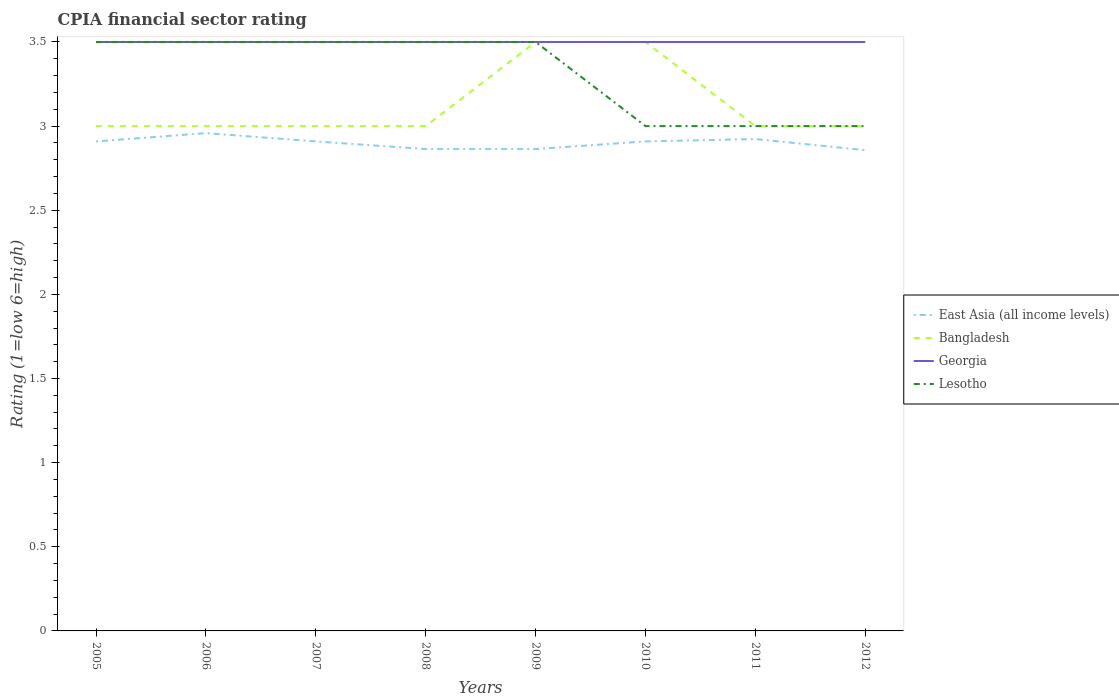Across all years, what is the maximum CPIA rating in Lesotho?
Provide a succinct answer. 3. What is the total CPIA rating in Georgia in the graph?
Ensure brevity in your answer.  0. What is the difference between the highest and the second highest CPIA rating in East Asia (all income levels)?
Offer a terse response. 0.1. How many years are there in the graph?
Ensure brevity in your answer.  8. What is the difference between two consecutive major ticks on the Y-axis?
Offer a terse response. 0.5. Are the values on the major ticks of Y-axis written in scientific E-notation?
Your response must be concise. No. Does the graph contain any zero values?
Offer a terse response. No. How many legend labels are there?
Make the answer very short. 4. How are the legend labels stacked?
Offer a terse response. Vertical. What is the title of the graph?
Your answer should be very brief. CPIA financial sector rating. What is the label or title of the X-axis?
Ensure brevity in your answer.  Years. What is the Rating (1=low 6=high) in East Asia (all income levels) in 2005?
Ensure brevity in your answer.  2.91. What is the Rating (1=low 6=high) in Bangladesh in 2005?
Your answer should be compact. 3. What is the Rating (1=low 6=high) in Georgia in 2005?
Make the answer very short. 3.5. What is the Rating (1=low 6=high) in Lesotho in 2005?
Offer a terse response. 3.5. What is the Rating (1=low 6=high) of East Asia (all income levels) in 2006?
Keep it short and to the point. 2.96. What is the Rating (1=low 6=high) of Georgia in 2006?
Your answer should be compact. 3.5. What is the Rating (1=low 6=high) in East Asia (all income levels) in 2007?
Provide a short and direct response. 2.91. What is the Rating (1=low 6=high) of Bangladesh in 2007?
Keep it short and to the point. 3. What is the Rating (1=low 6=high) in East Asia (all income levels) in 2008?
Your answer should be compact. 2.86. What is the Rating (1=low 6=high) in Lesotho in 2008?
Give a very brief answer. 3.5. What is the Rating (1=low 6=high) of East Asia (all income levels) in 2009?
Provide a short and direct response. 2.86. What is the Rating (1=low 6=high) in East Asia (all income levels) in 2010?
Your response must be concise. 2.91. What is the Rating (1=low 6=high) in Bangladesh in 2010?
Ensure brevity in your answer.  3.5. What is the Rating (1=low 6=high) of Georgia in 2010?
Your answer should be compact. 3.5. What is the Rating (1=low 6=high) in Lesotho in 2010?
Provide a short and direct response. 3. What is the Rating (1=low 6=high) of East Asia (all income levels) in 2011?
Your answer should be very brief. 2.92. What is the Rating (1=low 6=high) in East Asia (all income levels) in 2012?
Your response must be concise. 2.86. What is the Rating (1=low 6=high) of Lesotho in 2012?
Your answer should be very brief. 3. Across all years, what is the maximum Rating (1=low 6=high) of East Asia (all income levels)?
Ensure brevity in your answer.  2.96. Across all years, what is the maximum Rating (1=low 6=high) in Bangladesh?
Offer a terse response. 3.5. Across all years, what is the maximum Rating (1=low 6=high) of Georgia?
Your answer should be compact. 3.5. Across all years, what is the minimum Rating (1=low 6=high) of East Asia (all income levels)?
Keep it short and to the point. 2.86. Across all years, what is the minimum Rating (1=low 6=high) in Bangladesh?
Give a very brief answer. 3. What is the total Rating (1=low 6=high) in East Asia (all income levels) in the graph?
Offer a very short reply. 23.19. What is the total Rating (1=low 6=high) in Bangladesh in the graph?
Offer a terse response. 25. What is the total Rating (1=low 6=high) in Georgia in the graph?
Make the answer very short. 28. What is the total Rating (1=low 6=high) of Lesotho in the graph?
Your response must be concise. 26.5. What is the difference between the Rating (1=low 6=high) of East Asia (all income levels) in 2005 and that in 2006?
Offer a terse response. -0.05. What is the difference between the Rating (1=low 6=high) of Lesotho in 2005 and that in 2006?
Offer a very short reply. 0. What is the difference between the Rating (1=low 6=high) of East Asia (all income levels) in 2005 and that in 2007?
Provide a short and direct response. 0. What is the difference between the Rating (1=low 6=high) in East Asia (all income levels) in 2005 and that in 2008?
Ensure brevity in your answer.  0.05. What is the difference between the Rating (1=low 6=high) of Bangladesh in 2005 and that in 2008?
Offer a very short reply. 0. What is the difference between the Rating (1=low 6=high) in East Asia (all income levels) in 2005 and that in 2009?
Your answer should be very brief. 0.05. What is the difference between the Rating (1=low 6=high) in Georgia in 2005 and that in 2009?
Your response must be concise. 0. What is the difference between the Rating (1=low 6=high) in Lesotho in 2005 and that in 2009?
Ensure brevity in your answer.  0. What is the difference between the Rating (1=low 6=high) of Lesotho in 2005 and that in 2010?
Your response must be concise. 0.5. What is the difference between the Rating (1=low 6=high) of East Asia (all income levels) in 2005 and that in 2011?
Provide a succinct answer. -0.01. What is the difference between the Rating (1=low 6=high) of Georgia in 2005 and that in 2011?
Give a very brief answer. 0. What is the difference between the Rating (1=low 6=high) in Lesotho in 2005 and that in 2011?
Offer a terse response. 0.5. What is the difference between the Rating (1=low 6=high) of East Asia (all income levels) in 2005 and that in 2012?
Make the answer very short. 0.05. What is the difference between the Rating (1=low 6=high) in Bangladesh in 2005 and that in 2012?
Your answer should be compact. 0. What is the difference between the Rating (1=low 6=high) of Georgia in 2005 and that in 2012?
Provide a short and direct response. 0. What is the difference between the Rating (1=low 6=high) of East Asia (all income levels) in 2006 and that in 2007?
Offer a terse response. 0.05. What is the difference between the Rating (1=low 6=high) of Georgia in 2006 and that in 2007?
Your answer should be very brief. 0. What is the difference between the Rating (1=low 6=high) in East Asia (all income levels) in 2006 and that in 2008?
Keep it short and to the point. 0.09. What is the difference between the Rating (1=low 6=high) in Bangladesh in 2006 and that in 2008?
Provide a succinct answer. 0. What is the difference between the Rating (1=low 6=high) of Georgia in 2006 and that in 2008?
Provide a succinct answer. 0. What is the difference between the Rating (1=low 6=high) of Lesotho in 2006 and that in 2008?
Give a very brief answer. 0. What is the difference between the Rating (1=low 6=high) of East Asia (all income levels) in 2006 and that in 2009?
Make the answer very short. 0.09. What is the difference between the Rating (1=low 6=high) of Bangladesh in 2006 and that in 2009?
Your answer should be very brief. -0.5. What is the difference between the Rating (1=low 6=high) in Georgia in 2006 and that in 2009?
Your answer should be very brief. 0. What is the difference between the Rating (1=low 6=high) in East Asia (all income levels) in 2006 and that in 2010?
Provide a succinct answer. 0.05. What is the difference between the Rating (1=low 6=high) in Bangladesh in 2006 and that in 2010?
Ensure brevity in your answer.  -0.5. What is the difference between the Rating (1=low 6=high) of East Asia (all income levels) in 2006 and that in 2011?
Offer a terse response. 0.04. What is the difference between the Rating (1=low 6=high) in Bangladesh in 2006 and that in 2011?
Your response must be concise. 0. What is the difference between the Rating (1=low 6=high) in Georgia in 2006 and that in 2011?
Offer a very short reply. 0. What is the difference between the Rating (1=low 6=high) of Lesotho in 2006 and that in 2011?
Give a very brief answer. 0.5. What is the difference between the Rating (1=low 6=high) of East Asia (all income levels) in 2006 and that in 2012?
Your answer should be compact. 0.1. What is the difference between the Rating (1=low 6=high) in Lesotho in 2006 and that in 2012?
Keep it short and to the point. 0.5. What is the difference between the Rating (1=low 6=high) of East Asia (all income levels) in 2007 and that in 2008?
Offer a very short reply. 0.05. What is the difference between the Rating (1=low 6=high) in Bangladesh in 2007 and that in 2008?
Keep it short and to the point. 0. What is the difference between the Rating (1=low 6=high) in Lesotho in 2007 and that in 2008?
Offer a very short reply. 0. What is the difference between the Rating (1=low 6=high) in East Asia (all income levels) in 2007 and that in 2009?
Your response must be concise. 0.05. What is the difference between the Rating (1=low 6=high) of Bangladesh in 2007 and that in 2009?
Make the answer very short. -0.5. What is the difference between the Rating (1=low 6=high) in Georgia in 2007 and that in 2009?
Your response must be concise. 0. What is the difference between the Rating (1=low 6=high) in Georgia in 2007 and that in 2010?
Your answer should be compact. 0. What is the difference between the Rating (1=low 6=high) in East Asia (all income levels) in 2007 and that in 2011?
Your answer should be compact. -0.01. What is the difference between the Rating (1=low 6=high) in Bangladesh in 2007 and that in 2011?
Your answer should be very brief. 0. What is the difference between the Rating (1=low 6=high) in Georgia in 2007 and that in 2011?
Provide a short and direct response. 0. What is the difference between the Rating (1=low 6=high) in East Asia (all income levels) in 2007 and that in 2012?
Your response must be concise. 0.05. What is the difference between the Rating (1=low 6=high) of Lesotho in 2007 and that in 2012?
Offer a terse response. 0.5. What is the difference between the Rating (1=low 6=high) in East Asia (all income levels) in 2008 and that in 2010?
Provide a succinct answer. -0.05. What is the difference between the Rating (1=low 6=high) of Georgia in 2008 and that in 2010?
Provide a short and direct response. 0. What is the difference between the Rating (1=low 6=high) of East Asia (all income levels) in 2008 and that in 2011?
Keep it short and to the point. -0.06. What is the difference between the Rating (1=low 6=high) in Bangladesh in 2008 and that in 2011?
Your answer should be very brief. 0. What is the difference between the Rating (1=low 6=high) of Georgia in 2008 and that in 2011?
Keep it short and to the point. 0. What is the difference between the Rating (1=low 6=high) in Lesotho in 2008 and that in 2011?
Ensure brevity in your answer.  0.5. What is the difference between the Rating (1=low 6=high) in East Asia (all income levels) in 2008 and that in 2012?
Give a very brief answer. 0.01. What is the difference between the Rating (1=low 6=high) in Bangladesh in 2008 and that in 2012?
Your answer should be compact. 0. What is the difference between the Rating (1=low 6=high) in Lesotho in 2008 and that in 2012?
Provide a short and direct response. 0.5. What is the difference between the Rating (1=low 6=high) of East Asia (all income levels) in 2009 and that in 2010?
Provide a short and direct response. -0.05. What is the difference between the Rating (1=low 6=high) in Bangladesh in 2009 and that in 2010?
Ensure brevity in your answer.  0. What is the difference between the Rating (1=low 6=high) of Lesotho in 2009 and that in 2010?
Offer a very short reply. 0.5. What is the difference between the Rating (1=low 6=high) of East Asia (all income levels) in 2009 and that in 2011?
Provide a short and direct response. -0.06. What is the difference between the Rating (1=low 6=high) in East Asia (all income levels) in 2009 and that in 2012?
Your answer should be very brief. 0.01. What is the difference between the Rating (1=low 6=high) in Georgia in 2009 and that in 2012?
Provide a succinct answer. 0. What is the difference between the Rating (1=low 6=high) of Lesotho in 2009 and that in 2012?
Offer a terse response. 0.5. What is the difference between the Rating (1=low 6=high) in East Asia (all income levels) in 2010 and that in 2011?
Give a very brief answer. -0.01. What is the difference between the Rating (1=low 6=high) of Georgia in 2010 and that in 2011?
Give a very brief answer. 0. What is the difference between the Rating (1=low 6=high) of East Asia (all income levels) in 2010 and that in 2012?
Keep it short and to the point. 0.05. What is the difference between the Rating (1=low 6=high) of Georgia in 2010 and that in 2012?
Offer a very short reply. 0. What is the difference between the Rating (1=low 6=high) in East Asia (all income levels) in 2011 and that in 2012?
Provide a short and direct response. 0.07. What is the difference between the Rating (1=low 6=high) in East Asia (all income levels) in 2005 and the Rating (1=low 6=high) in Bangladesh in 2006?
Provide a short and direct response. -0.09. What is the difference between the Rating (1=low 6=high) in East Asia (all income levels) in 2005 and the Rating (1=low 6=high) in Georgia in 2006?
Ensure brevity in your answer.  -0.59. What is the difference between the Rating (1=low 6=high) in East Asia (all income levels) in 2005 and the Rating (1=low 6=high) in Lesotho in 2006?
Your answer should be very brief. -0.59. What is the difference between the Rating (1=low 6=high) of Georgia in 2005 and the Rating (1=low 6=high) of Lesotho in 2006?
Make the answer very short. 0. What is the difference between the Rating (1=low 6=high) of East Asia (all income levels) in 2005 and the Rating (1=low 6=high) of Bangladesh in 2007?
Offer a terse response. -0.09. What is the difference between the Rating (1=low 6=high) of East Asia (all income levels) in 2005 and the Rating (1=low 6=high) of Georgia in 2007?
Give a very brief answer. -0.59. What is the difference between the Rating (1=low 6=high) of East Asia (all income levels) in 2005 and the Rating (1=low 6=high) of Lesotho in 2007?
Your answer should be compact. -0.59. What is the difference between the Rating (1=low 6=high) of East Asia (all income levels) in 2005 and the Rating (1=low 6=high) of Bangladesh in 2008?
Offer a very short reply. -0.09. What is the difference between the Rating (1=low 6=high) of East Asia (all income levels) in 2005 and the Rating (1=low 6=high) of Georgia in 2008?
Ensure brevity in your answer.  -0.59. What is the difference between the Rating (1=low 6=high) of East Asia (all income levels) in 2005 and the Rating (1=low 6=high) of Lesotho in 2008?
Keep it short and to the point. -0.59. What is the difference between the Rating (1=low 6=high) in Bangladesh in 2005 and the Rating (1=low 6=high) in Georgia in 2008?
Offer a very short reply. -0.5. What is the difference between the Rating (1=low 6=high) of Bangladesh in 2005 and the Rating (1=low 6=high) of Lesotho in 2008?
Keep it short and to the point. -0.5. What is the difference between the Rating (1=low 6=high) in Georgia in 2005 and the Rating (1=low 6=high) in Lesotho in 2008?
Make the answer very short. 0. What is the difference between the Rating (1=low 6=high) in East Asia (all income levels) in 2005 and the Rating (1=low 6=high) in Bangladesh in 2009?
Provide a succinct answer. -0.59. What is the difference between the Rating (1=low 6=high) of East Asia (all income levels) in 2005 and the Rating (1=low 6=high) of Georgia in 2009?
Your answer should be compact. -0.59. What is the difference between the Rating (1=low 6=high) of East Asia (all income levels) in 2005 and the Rating (1=low 6=high) of Lesotho in 2009?
Offer a very short reply. -0.59. What is the difference between the Rating (1=low 6=high) in Bangladesh in 2005 and the Rating (1=low 6=high) in Lesotho in 2009?
Your answer should be very brief. -0.5. What is the difference between the Rating (1=low 6=high) of Georgia in 2005 and the Rating (1=low 6=high) of Lesotho in 2009?
Offer a terse response. 0. What is the difference between the Rating (1=low 6=high) in East Asia (all income levels) in 2005 and the Rating (1=low 6=high) in Bangladesh in 2010?
Your answer should be compact. -0.59. What is the difference between the Rating (1=low 6=high) of East Asia (all income levels) in 2005 and the Rating (1=low 6=high) of Georgia in 2010?
Your answer should be compact. -0.59. What is the difference between the Rating (1=low 6=high) in East Asia (all income levels) in 2005 and the Rating (1=low 6=high) in Lesotho in 2010?
Provide a succinct answer. -0.09. What is the difference between the Rating (1=low 6=high) of Bangladesh in 2005 and the Rating (1=low 6=high) of Georgia in 2010?
Provide a short and direct response. -0.5. What is the difference between the Rating (1=low 6=high) in East Asia (all income levels) in 2005 and the Rating (1=low 6=high) in Bangladesh in 2011?
Provide a succinct answer. -0.09. What is the difference between the Rating (1=low 6=high) in East Asia (all income levels) in 2005 and the Rating (1=low 6=high) in Georgia in 2011?
Ensure brevity in your answer.  -0.59. What is the difference between the Rating (1=low 6=high) in East Asia (all income levels) in 2005 and the Rating (1=low 6=high) in Lesotho in 2011?
Ensure brevity in your answer.  -0.09. What is the difference between the Rating (1=low 6=high) in Bangladesh in 2005 and the Rating (1=low 6=high) in Lesotho in 2011?
Your answer should be compact. 0. What is the difference between the Rating (1=low 6=high) in East Asia (all income levels) in 2005 and the Rating (1=low 6=high) in Bangladesh in 2012?
Your answer should be very brief. -0.09. What is the difference between the Rating (1=low 6=high) of East Asia (all income levels) in 2005 and the Rating (1=low 6=high) of Georgia in 2012?
Offer a very short reply. -0.59. What is the difference between the Rating (1=low 6=high) of East Asia (all income levels) in 2005 and the Rating (1=low 6=high) of Lesotho in 2012?
Provide a succinct answer. -0.09. What is the difference between the Rating (1=low 6=high) of Bangladesh in 2005 and the Rating (1=low 6=high) of Lesotho in 2012?
Offer a very short reply. 0. What is the difference between the Rating (1=low 6=high) in Georgia in 2005 and the Rating (1=low 6=high) in Lesotho in 2012?
Provide a succinct answer. 0.5. What is the difference between the Rating (1=low 6=high) of East Asia (all income levels) in 2006 and the Rating (1=low 6=high) of Bangladesh in 2007?
Your answer should be very brief. -0.04. What is the difference between the Rating (1=low 6=high) in East Asia (all income levels) in 2006 and the Rating (1=low 6=high) in Georgia in 2007?
Offer a terse response. -0.54. What is the difference between the Rating (1=low 6=high) in East Asia (all income levels) in 2006 and the Rating (1=low 6=high) in Lesotho in 2007?
Provide a succinct answer. -0.54. What is the difference between the Rating (1=low 6=high) in Bangladesh in 2006 and the Rating (1=low 6=high) in Lesotho in 2007?
Your response must be concise. -0.5. What is the difference between the Rating (1=low 6=high) of Georgia in 2006 and the Rating (1=low 6=high) of Lesotho in 2007?
Your answer should be very brief. 0. What is the difference between the Rating (1=low 6=high) in East Asia (all income levels) in 2006 and the Rating (1=low 6=high) in Bangladesh in 2008?
Give a very brief answer. -0.04. What is the difference between the Rating (1=low 6=high) in East Asia (all income levels) in 2006 and the Rating (1=low 6=high) in Georgia in 2008?
Make the answer very short. -0.54. What is the difference between the Rating (1=low 6=high) of East Asia (all income levels) in 2006 and the Rating (1=low 6=high) of Lesotho in 2008?
Provide a short and direct response. -0.54. What is the difference between the Rating (1=low 6=high) of Bangladesh in 2006 and the Rating (1=low 6=high) of Georgia in 2008?
Provide a short and direct response. -0.5. What is the difference between the Rating (1=low 6=high) of East Asia (all income levels) in 2006 and the Rating (1=low 6=high) of Bangladesh in 2009?
Offer a very short reply. -0.54. What is the difference between the Rating (1=low 6=high) in East Asia (all income levels) in 2006 and the Rating (1=low 6=high) in Georgia in 2009?
Offer a terse response. -0.54. What is the difference between the Rating (1=low 6=high) in East Asia (all income levels) in 2006 and the Rating (1=low 6=high) in Lesotho in 2009?
Provide a short and direct response. -0.54. What is the difference between the Rating (1=low 6=high) in Bangladesh in 2006 and the Rating (1=low 6=high) in Lesotho in 2009?
Your response must be concise. -0.5. What is the difference between the Rating (1=low 6=high) in Georgia in 2006 and the Rating (1=low 6=high) in Lesotho in 2009?
Offer a terse response. 0. What is the difference between the Rating (1=low 6=high) in East Asia (all income levels) in 2006 and the Rating (1=low 6=high) in Bangladesh in 2010?
Keep it short and to the point. -0.54. What is the difference between the Rating (1=low 6=high) of East Asia (all income levels) in 2006 and the Rating (1=low 6=high) of Georgia in 2010?
Offer a very short reply. -0.54. What is the difference between the Rating (1=low 6=high) in East Asia (all income levels) in 2006 and the Rating (1=low 6=high) in Lesotho in 2010?
Your answer should be compact. -0.04. What is the difference between the Rating (1=low 6=high) in East Asia (all income levels) in 2006 and the Rating (1=low 6=high) in Bangladesh in 2011?
Keep it short and to the point. -0.04. What is the difference between the Rating (1=low 6=high) of East Asia (all income levels) in 2006 and the Rating (1=low 6=high) of Georgia in 2011?
Your answer should be very brief. -0.54. What is the difference between the Rating (1=low 6=high) in East Asia (all income levels) in 2006 and the Rating (1=low 6=high) in Lesotho in 2011?
Make the answer very short. -0.04. What is the difference between the Rating (1=low 6=high) of Bangladesh in 2006 and the Rating (1=low 6=high) of Lesotho in 2011?
Make the answer very short. 0. What is the difference between the Rating (1=low 6=high) of Georgia in 2006 and the Rating (1=low 6=high) of Lesotho in 2011?
Provide a short and direct response. 0.5. What is the difference between the Rating (1=low 6=high) of East Asia (all income levels) in 2006 and the Rating (1=low 6=high) of Bangladesh in 2012?
Your answer should be very brief. -0.04. What is the difference between the Rating (1=low 6=high) of East Asia (all income levels) in 2006 and the Rating (1=low 6=high) of Georgia in 2012?
Provide a succinct answer. -0.54. What is the difference between the Rating (1=low 6=high) in East Asia (all income levels) in 2006 and the Rating (1=low 6=high) in Lesotho in 2012?
Make the answer very short. -0.04. What is the difference between the Rating (1=low 6=high) of Bangladesh in 2006 and the Rating (1=low 6=high) of Georgia in 2012?
Keep it short and to the point. -0.5. What is the difference between the Rating (1=low 6=high) of Bangladesh in 2006 and the Rating (1=low 6=high) of Lesotho in 2012?
Keep it short and to the point. 0. What is the difference between the Rating (1=low 6=high) of East Asia (all income levels) in 2007 and the Rating (1=low 6=high) of Bangladesh in 2008?
Ensure brevity in your answer.  -0.09. What is the difference between the Rating (1=low 6=high) in East Asia (all income levels) in 2007 and the Rating (1=low 6=high) in Georgia in 2008?
Make the answer very short. -0.59. What is the difference between the Rating (1=low 6=high) in East Asia (all income levels) in 2007 and the Rating (1=low 6=high) in Lesotho in 2008?
Your response must be concise. -0.59. What is the difference between the Rating (1=low 6=high) in Bangladesh in 2007 and the Rating (1=low 6=high) in Georgia in 2008?
Provide a short and direct response. -0.5. What is the difference between the Rating (1=low 6=high) in Bangladesh in 2007 and the Rating (1=low 6=high) in Lesotho in 2008?
Your response must be concise. -0.5. What is the difference between the Rating (1=low 6=high) in East Asia (all income levels) in 2007 and the Rating (1=low 6=high) in Bangladesh in 2009?
Give a very brief answer. -0.59. What is the difference between the Rating (1=low 6=high) in East Asia (all income levels) in 2007 and the Rating (1=low 6=high) in Georgia in 2009?
Make the answer very short. -0.59. What is the difference between the Rating (1=low 6=high) in East Asia (all income levels) in 2007 and the Rating (1=low 6=high) in Lesotho in 2009?
Provide a short and direct response. -0.59. What is the difference between the Rating (1=low 6=high) of Georgia in 2007 and the Rating (1=low 6=high) of Lesotho in 2009?
Your answer should be very brief. 0. What is the difference between the Rating (1=low 6=high) of East Asia (all income levels) in 2007 and the Rating (1=low 6=high) of Bangladesh in 2010?
Make the answer very short. -0.59. What is the difference between the Rating (1=low 6=high) of East Asia (all income levels) in 2007 and the Rating (1=low 6=high) of Georgia in 2010?
Your answer should be very brief. -0.59. What is the difference between the Rating (1=low 6=high) of East Asia (all income levels) in 2007 and the Rating (1=low 6=high) of Lesotho in 2010?
Offer a terse response. -0.09. What is the difference between the Rating (1=low 6=high) in Bangladesh in 2007 and the Rating (1=low 6=high) in Georgia in 2010?
Ensure brevity in your answer.  -0.5. What is the difference between the Rating (1=low 6=high) in Bangladesh in 2007 and the Rating (1=low 6=high) in Lesotho in 2010?
Give a very brief answer. 0. What is the difference between the Rating (1=low 6=high) of Georgia in 2007 and the Rating (1=low 6=high) of Lesotho in 2010?
Offer a very short reply. 0.5. What is the difference between the Rating (1=low 6=high) of East Asia (all income levels) in 2007 and the Rating (1=low 6=high) of Bangladesh in 2011?
Offer a very short reply. -0.09. What is the difference between the Rating (1=low 6=high) of East Asia (all income levels) in 2007 and the Rating (1=low 6=high) of Georgia in 2011?
Ensure brevity in your answer.  -0.59. What is the difference between the Rating (1=low 6=high) in East Asia (all income levels) in 2007 and the Rating (1=low 6=high) in Lesotho in 2011?
Give a very brief answer. -0.09. What is the difference between the Rating (1=low 6=high) in East Asia (all income levels) in 2007 and the Rating (1=low 6=high) in Bangladesh in 2012?
Your answer should be compact. -0.09. What is the difference between the Rating (1=low 6=high) in East Asia (all income levels) in 2007 and the Rating (1=low 6=high) in Georgia in 2012?
Ensure brevity in your answer.  -0.59. What is the difference between the Rating (1=low 6=high) of East Asia (all income levels) in 2007 and the Rating (1=low 6=high) of Lesotho in 2012?
Ensure brevity in your answer.  -0.09. What is the difference between the Rating (1=low 6=high) of Bangladesh in 2007 and the Rating (1=low 6=high) of Georgia in 2012?
Your answer should be compact. -0.5. What is the difference between the Rating (1=low 6=high) of Bangladesh in 2007 and the Rating (1=low 6=high) of Lesotho in 2012?
Your answer should be very brief. 0. What is the difference between the Rating (1=low 6=high) in Georgia in 2007 and the Rating (1=low 6=high) in Lesotho in 2012?
Give a very brief answer. 0.5. What is the difference between the Rating (1=low 6=high) of East Asia (all income levels) in 2008 and the Rating (1=low 6=high) of Bangladesh in 2009?
Your answer should be compact. -0.64. What is the difference between the Rating (1=low 6=high) in East Asia (all income levels) in 2008 and the Rating (1=low 6=high) in Georgia in 2009?
Your answer should be very brief. -0.64. What is the difference between the Rating (1=low 6=high) of East Asia (all income levels) in 2008 and the Rating (1=low 6=high) of Lesotho in 2009?
Offer a very short reply. -0.64. What is the difference between the Rating (1=low 6=high) of Bangladesh in 2008 and the Rating (1=low 6=high) of Lesotho in 2009?
Offer a terse response. -0.5. What is the difference between the Rating (1=low 6=high) in Georgia in 2008 and the Rating (1=low 6=high) in Lesotho in 2009?
Keep it short and to the point. 0. What is the difference between the Rating (1=low 6=high) of East Asia (all income levels) in 2008 and the Rating (1=low 6=high) of Bangladesh in 2010?
Your response must be concise. -0.64. What is the difference between the Rating (1=low 6=high) of East Asia (all income levels) in 2008 and the Rating (1=low 6=high) of Georgia in 2010?
Your response must be concise. -0.64. What is the difference between the Rating (1=low 6=high) of East Asia (all income levels) in 2008 and the Rating (1=low 6=high) of Lesotho in 2010?
Ensure brevity in your answer.  -0.14. What is the difference between the Rating (1=low 6=high) in Bangladesh in 2008 and the Rating (1=low 6=high) in Lesotho in 2010?
Offer a terse response. 0. What is the difference between the Rating (1=low 6=high) of Georgia in 2008 and the Rating (1=low 6=high) of Lesotho in 2010?
Make the answer very short. 0.5. What is the difference between the Rating (1=low 6=high) of East Asia (all income levels) in 2008 and the Rating (1=low 6=high) of Bangladesh in 2011?
Give a very brief answer. -0.14. What is the difference between the Rating (1=low 6=high) of East Asia (all income levels) in 2008 and the Rating (1=low 6=high) of Georgia in 2011?
Your response must be concise. -0.64. What is the difference between the Rating (1=low 6=high) of East Asia (all income levels) in 2008 and the Rating (1=low 6=high) of Lesotho in 2011?
Your answer should be compact. -0.14. What is the difference between the Rating (1=low 6=high) of Bangladesh in 2008 and the Rating (1=low 6=high) of Georgia in 2011?
Make the answer very short. -0.5. What is the difference between the Rating (1=low 6=high) in Bangladesh in 2008 and the Rating (1=low 6=high) in Lesotho in 2011?
Your answer should be very brief. 0. What is the difference between the Rating (1=low 6=high) in Georgia in 2008 and the Rating (1=low 6=high) in Lesotho in 2011?
Your answer should be very brief. 0.5. What is the difference between the Rating (1=low 6=high) of East Asia (all income levels) in 2008 and the Rating (1=low 6=high) of Bangladesh in 2012?
Offer a very short reply. -0.14. What is the difference between the Rating (1=low 6=high) of East Asia (all income levels) in 2008 and the Rating (1=low 6=high) of Georgia in 2012?
Provide a succinct answer. -0.64. What is the difference between the Rating (1=low 6=high) of East Asia (all income levels) in 2008 and the Rating (1=low 6=high) of Lesotho in 2012?
Your response must be concise. -0.14. What is the difference between the Rating (1=low 6=high) in Georgia in 2008 and the Rating (1=low 6=high) in Lesotho in 2012?
Make the answer very short. 0.5. What is the difference between the Rating (1=low 6=high) of East Asia (all income levels) in 2009 and the Rating (1=low 6=high) of Bangladesh in 2010?
Provide a succinct answer. -0.64. What is the difference between the Rating (1=low 6=high) in East Asia (all income levels) in 2009 and the Rating (1=low 6=high) in Georgia in 2010?
Offer a terse response. -0.64. What is the difference between the Rating (1=low 6=high) of East Asia (all income levels) in 2009 and the Rating (1=low 6=high) of Lesotho in 2010?
Make the answer very short. -0.14. What is the difference between the Rating (1=low 6=high) of Bangladesh in 2009 and the Rating (1=low 6=high) of Lesotho in 2010?
Ensure brevity in your answer.  0.5. What is the difference between the Rating (1=low 6=high) of Georgia in 2009 and the Rating (1=low 6=high) of Lesotho in 2010?
Keep it short and to the point. 0.5. What is the difference between the Rating (1=low 6=high) of East Asia (all income levels) in 2009 and the Rating (1=low 6=high) of Bangladesh in 2011?
Offer a terse response. -0.14. What is the difference between the Rating (1=low 6=high) in East Asia (all income levels) in 2009 and the Rating (1=low 6=high) in Georgia in 2011?
Keep it short and to the point. -0.64. What is the difference between the Rating (1=low 6=high) of East Asia (all income levels) in 2009 and the Rating (1=low 6=high) of Lesotho in 2011?
Make the answer very short. -0.14. What is the difference between the Rating (1=low 6=high) of Bangladesh in 2009 and the Rating (1=low 6=high) of Georgia in 2011?
Your answer should be very brief. 0. What is the difference between the Rating (1=low 6=high) in Bangladesh in 2009 and the Rating (1=low 6=high) in Lesotho in 2011?
Offer a very short reply. 0.5. What is the difference between the Rating (1=low 6=high) of East Asia (all income levels) in 2009 and the Rating (1=low 6=high) of Bangladesh in 2012?
Your answer should be very brief. -0.14. What is the difference between the Rating (1=low 6=high) in East Asia (all income levels) in 2009 and the Rating (1=low 6=high) in Georgia in 2012?
Your response must be concise. -0.64. What is the difference between the Rating (1=low 6=high) of East Asia (all income levels) in 2009 and the Rating (1=low 6=high) of Lesotho in 2012?
Provide a short and direct response. -0.14. What is the difference between the Rating (1=low 6=high) of Bangladesh in 2009 and the Rating (1=low 6=high) of Georgia in 2012?
Ensure brevity in your answer.  0. What is the difference between the Rating (1=low 6=high) of Bangladesh in 2009 and the Rating (1=low 6=high) of Lesotho in 2012?
Offer a very short reply. 0.5. What is the difference between the Rating (1=low 6=high) of East Asia (all income levels) in 2010 and the Rating (1=low 6=high) of Bangladesh in 2011?
Keep it short and to the point. -0.09. What is the difference between the Rating (1=low 6=high) of East Asia (all income levels) in 2010 and the Rating (1=low 6=high) of Georgia in 2011?
Make the answer very short. -0.59. What is the difference between the Rating (1=low 6=high) of East Asia (all income levels) in 2010 and the Rating (1=low 6=high) of Lesotho in 2011?
Provide a succinct answer. -0.09. What is the difference between the Rating (1=low 6=high) of Bangladesh in 2010 and the Rating (1=low 6=high) of Lesotho in 2011?
Your response must be concise. 0.5. What is the difference between the Rating (1=low 6=high) in Georgia in 2010 and the Rating (1=low 6=high) in Lesotho in 2011?
Offer a terse response. 0.5. What is the difference between the Rating (1=low 6=high) of East Asia (all income levels) in 2010 and the Rating (1=low 6=high) of Bangladesh in 2012?
Provide a short and direct response. -0.09. What is the difference between the Rating (1=low 6=high) in East Asia (all income levels) in 2010 and the Rating (1=low 6=high) in Georgia in 2012?
Make the answer very short. -0.59. What is the difference between the Rating (1=low 6=high) of East Asia (all income levels) in 2010 and the Rating (1=low 6=high) of Lesotho in 2012?
Provide a short and direct response. -0.09. What is the difference between the Rating (1=low 6=high) of East Asia (all income levels) in 2011 and the Rating (1=low 6=high) of Bangladesh in 2012?
Your response must be concise. -0.08. What is the difference between the Rating (1=low 6=high) in East Asia (all income levels) in 2011 and the Rating (1=low 6=high) in Georgia in 2012?
Keep it short and to the point. -0.58. What is the difference between the Rating (1=low 6=high) of East Asia (all income levels) in 2011 and the Rating (1=low 6=high) of Lesotho in 2012?
Give a very brief answer. -0.08. What is the difference between the Rating (1=low 6=high) in Bangladesh in 2011 and the Rating (1=low 6=high) in Lesotho in 2012?
Ensure brevity in your answer.  0. What is the difference between the Rating (1=low 6=high) in Georgia in 2011 and the Rating (1=low 6=high) in Lesotho in 2012?
Give a very brief answer. 0.5. What is the average Rating (1=low 6=high) in East Asia (all income levels) per year?
Give a very brief answer. 2.9. What is the average Rating (1=low 6=high) of Bangladesh per year?
Make the answer very short. 3.12. What is the average Rating (1=low 6=high) of Lesotho per year?
Make the answer very short. 3.31. In the year 2005, what is the difference between the Rating (1=low 6=high) in East Asia (all income levels) and Rating (1=low 6=high) in Bangladesh?
Your answer should be very brief. -0.09. In the year 2005, what is the difference between the Rating (1=low 6=high) of East Asia (all income levels) and Rating (1=low 6=high) of Georgia?
Provide a succinct answer. -0.59. In the year 2005, what is the difference between the Rating (1=low 6=high) in East Asia (all income levels) and Rating (1=low 6=high) in Lesotho?
Make the answer very short. -0.59. In the year 2005, what is the difference between the Rating (1=low 6=high) in Bangladesh and Rating (1=low 6=high) in Georgia?
Offer a terse response. -0.5. In the year 2005, what is the difference between the Rating (1=low 6=high) in Georgia and Rating (1=low 6=high) in Lesotho?
Keep it short and to the point. 0. In the year 2006, what is the difference between the Rating (1=low 6=high) of East Asia (all income levels) and Rating (1=low 6=high) of Bangladesh?
Offer a terse response. -0.04. In the year 2006, what is the difference between the Rating (1=low 6=high) of East Asia (all income levels) and Rating (1=low 6=high) of Georgia?
Your answer should be compact. -0.54. In the year 2006, what is the difference between the Rating (1=low 6=high) of East Asia (all income levels) and Rating (1=low 6=high) of Lesotho?
Your answer should be very brief. -0.54. In the year 2006, what is the difference between the Rating (1=low 6=high) of Bangladesh and Rating (1=low 6=high) of Georgia?
Provide a succinct answer. -0.5. In the year 2006, what is the difference between the Rating (1=low 6=high) of Georgia and Rating (1=low 6=high) of Lesotho?
Give a very brief answer. 0. In the year 2007, what is the difference between the Rating (1=low 6=high) in East Asia (all income levels) and Rating (1=low 6=high) in Bangladesh?
Offer a terse response. -0.09. In the year 2007, what is the difference between the Rating (1=low 6=high) of East Asia (all income levels) and Rating (1=low 6=high) of Georgia?
Your response must be concise. -0.59. In the year 2007, what is the difference between the Rating (1=low 6=high) in East Asia (all income levels) and Rating (1=low 6=high) in Lesotho?
Your answer should be very brief. -0.59. In the year 2008, what is the difference between the Rating (1=low 6=high) of East Asia (all income levels) and Rating (1=low 6=high) of Bangladesh?
Your response must be concise. -0.14. In the year 2008, what is the difference between the Rating (1=low 6=high) in East Asia (all income levels) and Rating (1=low 6=high) in Georgia?
Ensure brevity in your answer.  -0.64. In the year 2008, what is the difference between the Rating (1=low 6=high) of East Asia (all income levels) and Rating (1=low 6=high) of Lesotho?
Offer a very short reply. -0.64. In the year 2008, what is the difference between the Rating (1=low 6=high) of Bangladesh and Rating (1=low 6=high) of Lesotho?
Provide a short and direct response. -0.5. In the year 2008, what is the difference between the Rating (1=low 6=high) of Georgia and Rating (1=low 6=high) of Lesotho?
Offer a terse response. 0. In the year 2009, what is the difference between the Rating (1=low 6=high) in East Asia (all income levels) and Rating (1=low 6=high) in Bangladesh?
Your answer should be compact. -0.64. In the year 2009, what is the difference between the Rating (1=low 6=high) in East Asia (all income levels) and Rating (1=low 6=high) in Georgia?
Offer a very short reply. -0.64. In the year 2009, what is the difference between the Rating (1=low 6=high) of East Asia (all income levels) and Rating (1=low 6=high) of Lesotho?
Provide a short and direct response. -0.64. In the year 2009, what is the difference between the Rating (1=low 6=high) in Georgia and Rating (1=low 6=high) in Lesotho?
Provide a short and direct response. 0. In the year 2010, what is the difference between the Rating (1=low 6=high) in East Asia (all income levels) and Rating (1=low 6=high) in Bangladesh?
Ensure brevity in your answer.  -0.59. In the year 2010, what is the difference between the Rating (1=low 6=high) of East Asia (all income levels) and Rating (1=low 6=high) of Georgia?
Your answer should be compact. -0.59. In the year 2010, what is the difference between the Rating (1=low 6=high) in East Asia (all income levels) and Rating (1=low 6=high) in Lesotho?
Your response must be concise. -0.09. In the year 2010, what is the difference between the Rating (1=low 6=high) of Georgia and Rating (1=low 6=high) of Lesotho?
Offer a very short reply. 0.5. In the year 2011, what is the difference between the Rating (1=low 6=high) in East Asia (all income levels) and Rating (1=low 6=high) in Bangladesh?
Keep it short and to the point. -0.08. In the year 2011, what is the difference between the Rating (1=low 6=high) of East Asia (all income levels) and Rating (1=low 6=high) of Georgia?
Offer a very short reply. -0.58. In the year 2011, what is the difference between the Rating (1=low 6=high) of East Asia (all income levels) and Rating (1=low 6=high) of Lesotho?
Make the answer very short. -0.08. In the year 2011, what is the difference between the Rating (1=low 6=high) of Bangladesh and Rating (1=low 6=high) of Lesotho?
Your answer should be very brief. 0. In the year 2011, what is the difference between the Rating (1=low 6=high) of Georgia and Rating (1=low 6=high) of Lesotho?
Offer a terse response. 0.5. In the year 2012, what is the difference between the Rating (1=low 6=high) of East Asia (all income levels) and Rating (1=low 6=high) of Bangladesh?
Make the answer very short. -0.14. In the year 2012, what is the difference between the Rating (1=low 6=high) in East Asia (all income levels) and Rating (1=low 6=high) in Georgia?
Your answer should be very brief. -0.64. In the year 2012, what is the difference between the Rating (1=low 6=high) in East Asia (all income levels) and Rating (1=low 6=high) in Lesotho?
Provide a succinct answer. -0.14. In the year 2012, what is the difference between the Rating (1=low 6=high) of Bangladesh and Rating (1=low 6=high) of Georgia?
Make the answer very short. -0.5. In the year 2012, what is the difference between the Rating (1=low 6=high) of Georgia and Rating (1=low 6=high) of Lesotho?
Your response must be concise. 0.5. What is the ratio of the Rating (1=low 6=high) of East Asia (all income levels) in 2005 to that in 2006?
Offer a very short reply. 0.98. What is the ratio of the Rating (1=low 6=high) of Georgia in 2005 to that in 2006?
Keep it short and to the point. 1. What is the ratio of the Rating (1=low 6=high) in Lesotho in 2005 to that in 2006?
Ensure brevity in your answer.  1. What is the ratio of the Rating (1=low 6=high) of Georgia in 2005 to that in 2007?
Provide a succinct answer. 1. What is the ratio of the Rating (1=low 6=high) of Lesotho in 2005 to that in 2007?
Ensure brevity in your answer.  1. What is the ratio of the Rating (1=low 6=high) in East Asia (all income levels) in 2005 to that in 2008?
Your answer should be very brief. 1.02. What is the ratio of the Rating (1=low 6=high) of Bangladesh in 2005 to that in 2008?
Keep it short and to the point. 1. What is the ratio of the Rating (1=low 6=high) in East Asia (all income levels) in 2005 to that in 2009?
Make the answer very short. 1.02. What is the ratio of the Rating (1=low 6=high) in Georgia in 2005 to that in 2009?
Your answer should be very brief. 1. What is the ratio of the Rating (1=low 6=high) in Lesotho in 2005 to that in 2009?
Offer a very short reply. 1. What is the ratio of the Rating (1=low 6=high) in Bangladesh in 2005 to that in 2010?
Ensure brevity in your answer.  0.86. What is the ratio of the Rating (1=low 6=high) in Bangladesh in 2005 to that in 2011?
Your response must be concise. 1. What is the ratio of the Rating (1=low 6=high) of Lesotho in 2005 to that in 2011?
Keep it short and to the point. 1.17. What is the ratio of the Rating (1=low 6=high) in East Asia (all income levels) in 2005 to that in 2012?
Make the answer very short. 1.02. What is the ratio of the Rating (1=low 6=high) in Bangladesh in 2005 to that in 2012?
Your answer should be very brief. 1. What is the ratio of the Rating (1=low 6=high) of Lesotho in 2005 to that in 2012?
Offer a terse response. 1.17. What is the ratio of the Rating (1=low 6=high) of East Asia (all income levels) in 2006 to that in 2007?
Provide a succinct answer. 1.02. What is the ratio of the Rating (1=low 6=high) of Bangladesh in 2006 to that in 2007?
Provide a short and direct response. 1. What is the ratio of the Rating (1=low 6=high) in East Asia (all income levels) in 2006 to that in 2008?
Provide a short and direct response. 1.03. What is the ratio of the Rating (1=low 6=high) in Lesotho in 2006 to that in 2008?
Your response must be concise. 1. What is the ratio of the Rating (1=low 6=high) in East Asia (all income levels) in 2006 to that in 2009?
Provide a succinct answer. 1.03. What is the ratio of the Rating (1=low 6=high) of Bangladesh in 2006 to that in 2009?
Your answer should be very brief. 0.86. What is the ratio of the Rating (1=low 6=high) of East Asia (all income levels) in 2006 to that in 2010?
Ensure brevity in your answer.  1.02. What is the ratio of the Rating (1=low 6=high) in Lesotho in 2006 to that in 2010?
Keep it short and to the point. 1.17. What is the ratio of the Rating (1=low 6=high) in East Asia (all income levels) in 2006 to that in 2011?
Provide a short and direct response. 1.01. What is the ratio of the Rating (1=low 6=high) of Lesotho in 2006 to that in 2011?
Keep it short and to the point. 1.17. What is the ratio of the Rating (1=low 6=high) in East Asia (all income levels) in 2006 to that in 2012?
Make the answer very short. 1.04. What is the ratio of the Rating (1=low 6=high) in Bangladesh in 2006 to that in 2012?
Make the answer very short. 1. What is the ratio of the Rating (1=low 6=high) of Georgia in 2006 to that in 2012?
Offer a very short reply. 1. What is the ratio of the Rating (1=low 6=high) of Lesotho in 2006 to that in 2012?
Offer a very short reply. 1.17. What is the ratio of the Rating (1=low 6=high) of East Asia (all income levels) in 2007 to that in 2008?
Provide a short and direct response. 1.02. What is the ratio of the Rating (1=low 6=high) of Georgia in 2007 to that in 2008?
Your answer should be very brief. 1. What is the ratio of the Rating (1=low 6=high) in Lesotho in 2007 to that in 2008?
Your answer should be compact. 1. What is the ratio of the Rating (1=low 6=high) of East Asia (all income levels) in 2007 to that in 2009?
Provide a succinct answer. 1.02. What is the ratio of the Rating (1=low 6=high) in Lesotho in 2007 to that in 2009?
Make the answer very short. 1. What is the ratio of the Rating (1=low 6=high) of Bangladesh in 2007 to that in 2011?
Your response must be concise. 1. What is the ratio of the Rating (1=low 6=high) in Georgia in 2007 to that in 2011?
Offer a terse response. 1. What is the ratio of the Rating (1=low 6=high) in Lesotho in 2007 to that in 2011?
Keep it short and to the point. 1.17. What is the ratio of the Rating (1=low 6=high) in East Asia (all income levels) in 2007 to that in 2012?
Your response must be concise. 1.02. What is the ratio of the Rating (1=low 6=high) of Bangladesh in 2007 to that in 2012?
Offer a very short reply. 1. What is the ratio of the Rating (1=low 6=high) of Lesotho in 2007 to that in 2012?
Offer a terse response. 1.17. What is the ratio of the Rating (1=low 6=high) in East Asia (all income levels) in 2008 to that in 2010?
Provide a succinct answer. 0.98. What is the ratio of the Rating (1=low 6=high) of Bangladesh in 2008 to that in 2010?
Your answer should be compact. 0.86. What is the ratio of the Rating (1=low 6=high) of Georgia in 2008 to that in 2010?
Provide a short and direct response. 1. What is the ratio of the Rating (1=low 6=high) of East Asia (all income levels) in 2008 to that in 2011?
Ensure brevity in your answer.  0.98. What is the ratio of the Rating (1=low 6=high) in Bangladesh in 2008 to that in 2011?
Your answer should be compact. 1. What is the ratio of the Rating (1=low 6=high) of Georgia in 2008 to that in 2011?
Offer a terse response. 1. What is the ratio of the Rating (1=low 6=high) in Bangladesh in 2008 to that in 2012?
Make the answer very short. 1. What is the ratio of the Rating (1=low 6=high) of Georgia in 2008 to that in 2012?
Keep it short and to the point. 1. What is the ratio of the Rating (1=low 6=high) in Lesotho in 2008 to that in 2012?
Your answer should be compact. 1.17. What is the ratio of the Rating (1=low 6=high) of East Asia (all income levels) in 2009 to that in 2010?
Provide a short and direct response. 0.98. What is the ratio of the Rating (1=low 6=high) of Bangladesh in 2009 to that in 2010?
Offer a very short reply. 1. What is the ratio of the Rating (1=low 6=high) in Lesotho in 2009 to that in 2010?
Make the answer very short. 1.17. What is the ratio of the Rating (1=low 6=high) of East Asia (all income levels) in 2009 to that in 2011?
Your answer should be very brief. 0.98. What is the ratio of the Rating (1=low 6=high) in Georgia in 2009 to that in 2011?
Give a very brief answer. 1. What is the ratio of the Rating (1=low 6=high) of Bangladesh in 2009 to that in 2012?
Provide a short and direct response. 1.17. What is the ratio of the Rating (1=low 6=high) in Bangladesh in 2010 to that in 2011?
Give a very brief answer. 1.17. What is the ratio of the Rating (1=low 6=high) in Georgia in 2010 to that in 2011?
Offer a very short reply. 1. What is the ratio of the Rating (1=low 6=high) of East Asia (all income levels) in 2010 to that in 2012?
Offer a very short reply. 1.02. What is the ratio of the Rating (1=low 6=high) of Bangladesh in 2010 to that in 2012?
Give a very brief answer. 1.17. What is the ratio of the Rating (1=low 6=high) of East Asia (all income levels) in 2011 to that in 2012?
Provide a short and direct response. 1.02. What is the ratio of the Rating (1=low 6=high) of Georgia in 2011 to that in 2012?
Make the answer very short. 1. What is the difference between the highest and the second highest Rating (1=low 6=high) in East Asia (all income levels)?
Give a very brief answer. 0.04. What is the difference between the highest and the lowest Rating (1=low 6=high) in East Asia (all income levels)?
Your answer should be compact. 0.1. What is the difference between the highest and the lowest Rating (1=low 6=high) of Bangladesh?
Make the answer very short. 0.5. What is the difference between the highest and the lowest Rating (1=low 6=high) of Georgia?
Your answer should be very brief. 0. 